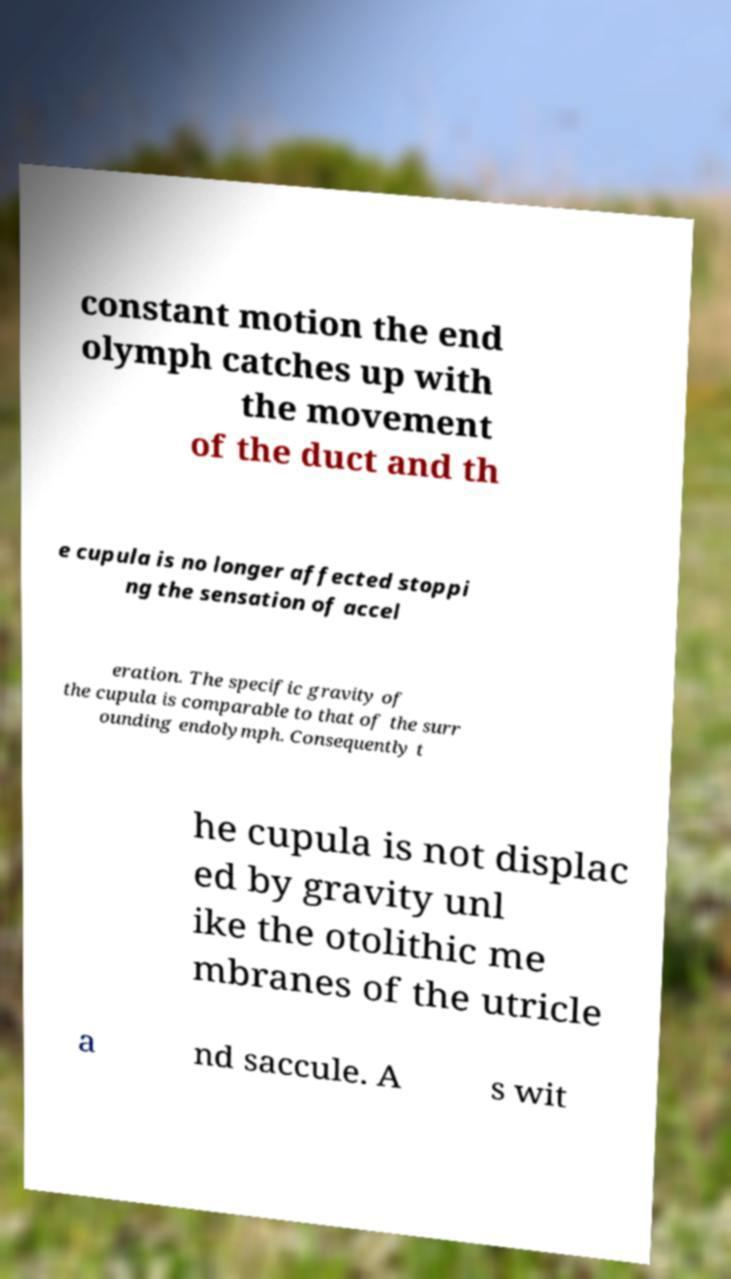Please read and relay the text visible in this image. What does it say? constant motion the end olymph catches up with the movement of the duct and th e cupula is no longer affected stoppi ng the sensation of accel eration. The specific gravity of the cupula is comparable to that of the surr ounding endolymph. Consequently t he cupula is not displac ed by gravity unl ike the otolithic me mbranes of the utricle a nd saccule. A s wit 